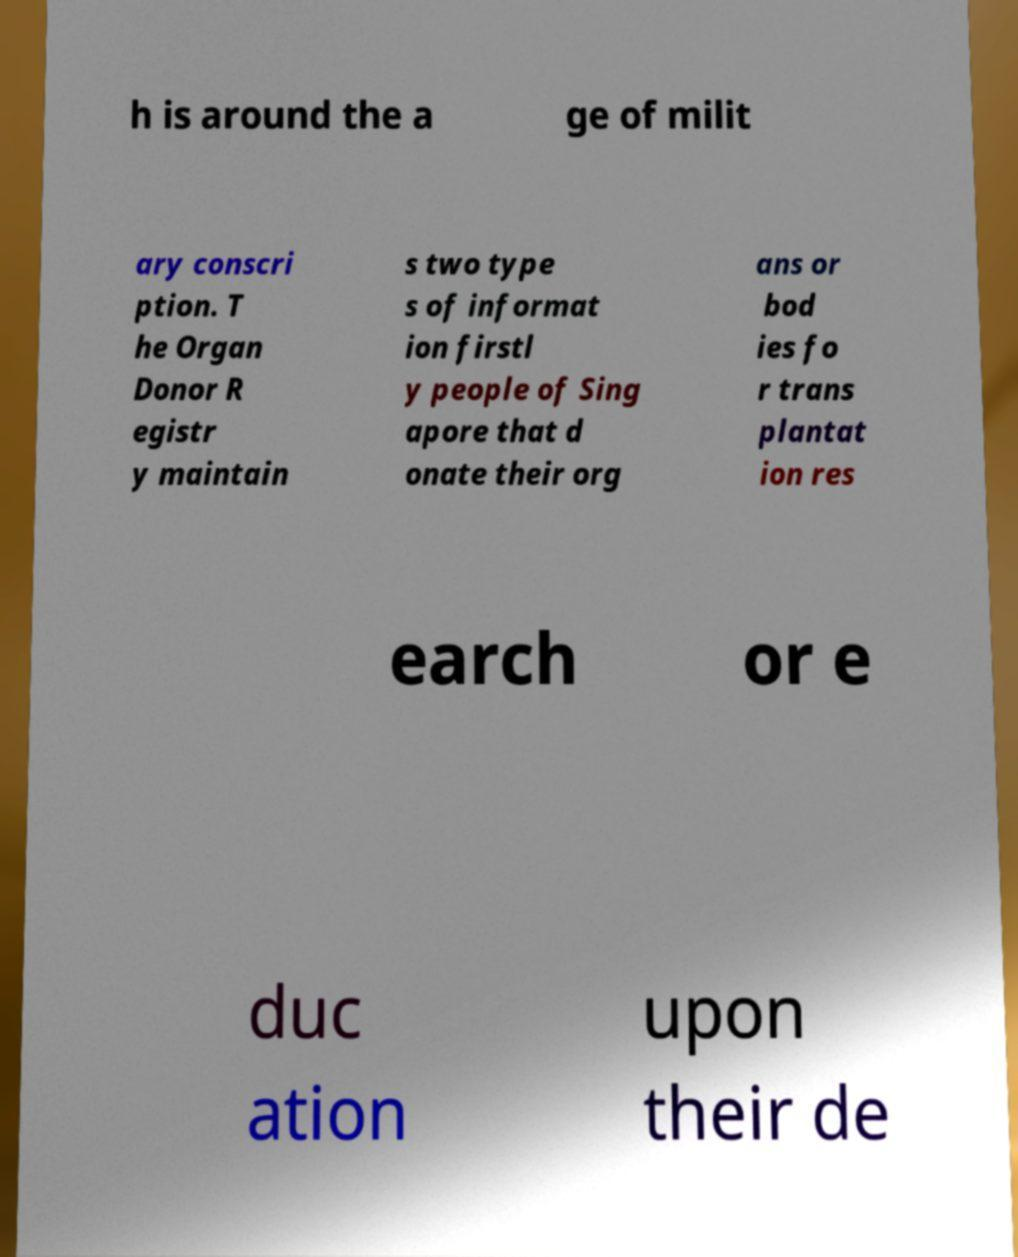What messages or text are displayed in this image? I need them in a readable, typed format. h is around the a ge of milit ary conscri ption. T he Organ Donor R egistr y maintain s two type s of informat ion firstl y people of Sing apore that d onate their org ans or bod ies fo r trans plantat ion res earch or e duc ation upon their de 